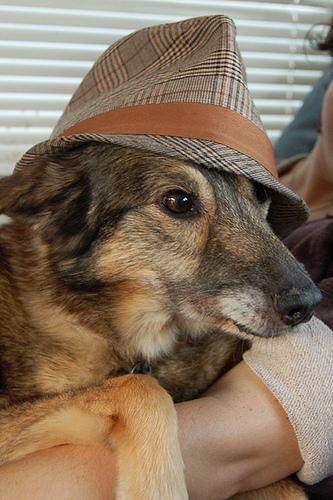How many dogs are there?
Give a very brief answer. 1. 